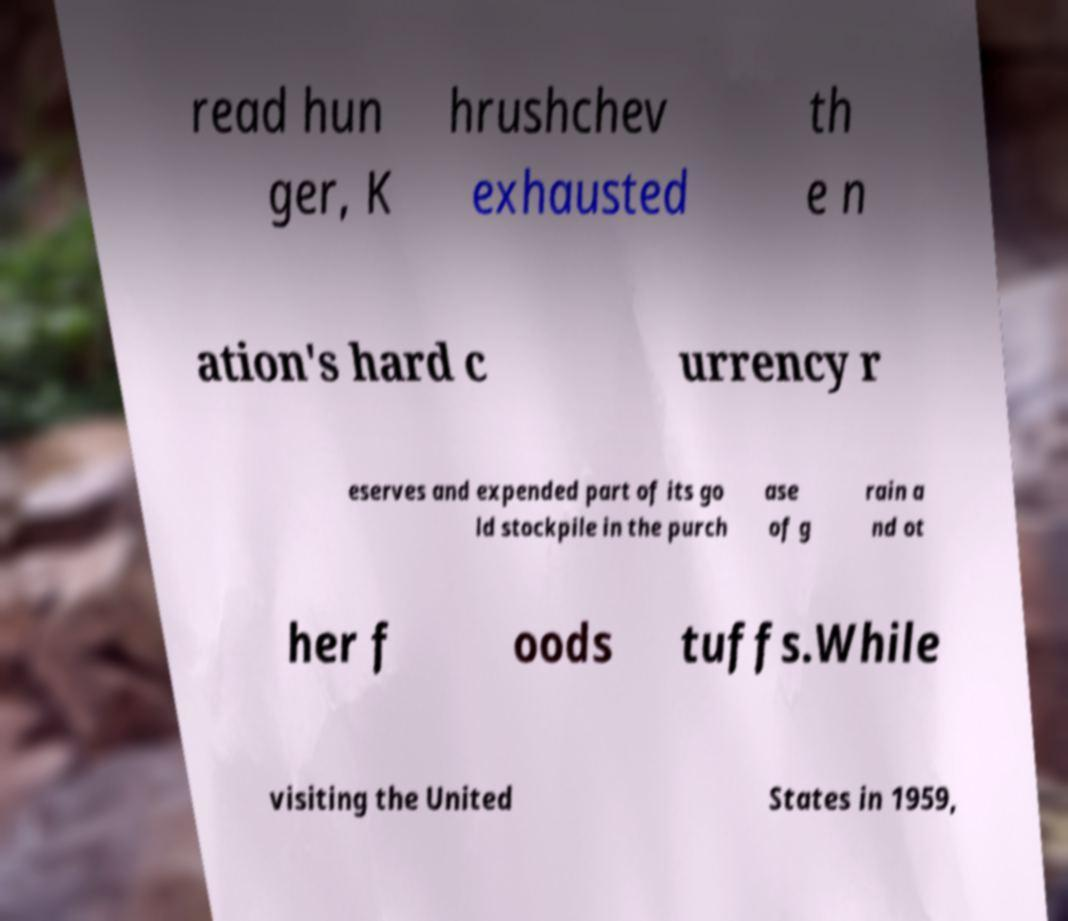Could you assist in decoding the text presented in this image and type it out clearly? read hun ger, K hrushchev exhausted th e n ation's hard c urrency r eserves and expended part of its go ld stockpile in the purch ase of g rain a nd ot her f oods tuffs.While visiting the United States in 1959, 